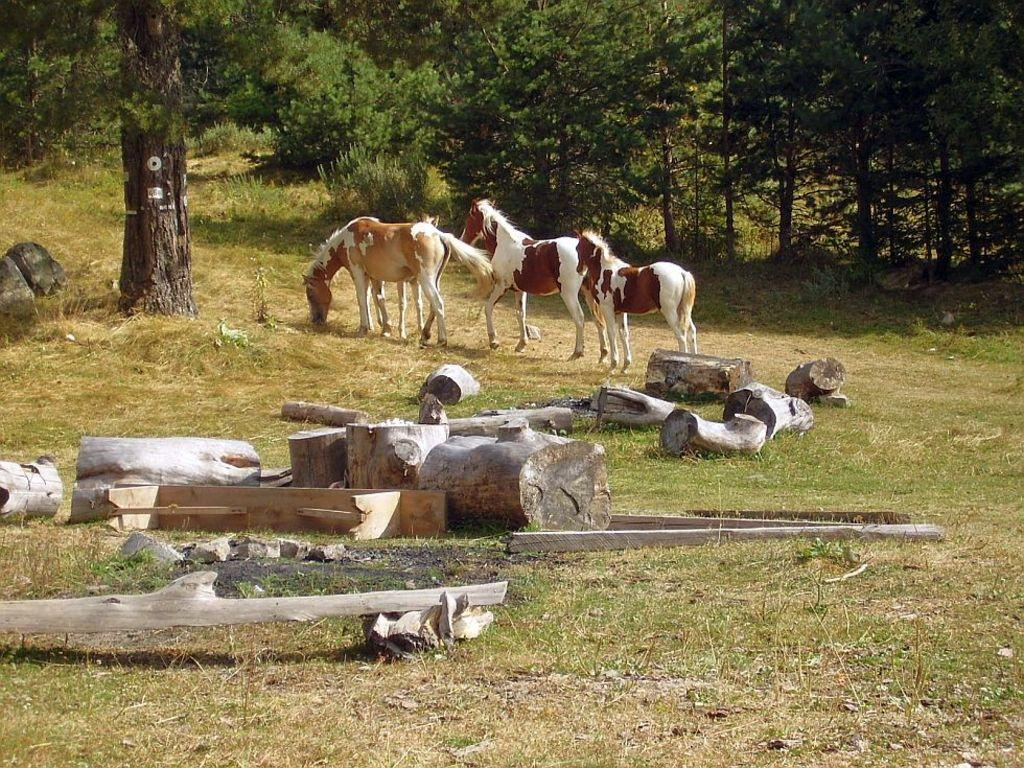How many horses are in the image? There are three horses in the image. What are the horses doing in the image? The horses are walking on the ground. What type of terrain can be seen in the image? There is grass on the ground. What objects are present in the foreground of the image? There are logs of wood in the foreground. What can be seen in the background of the image? There are plants and trees in the background. What type of paper is being sorted in the cemetery in the image? There is no cemetery or paper present in the image; it features three horses walking on grassy terrain. 